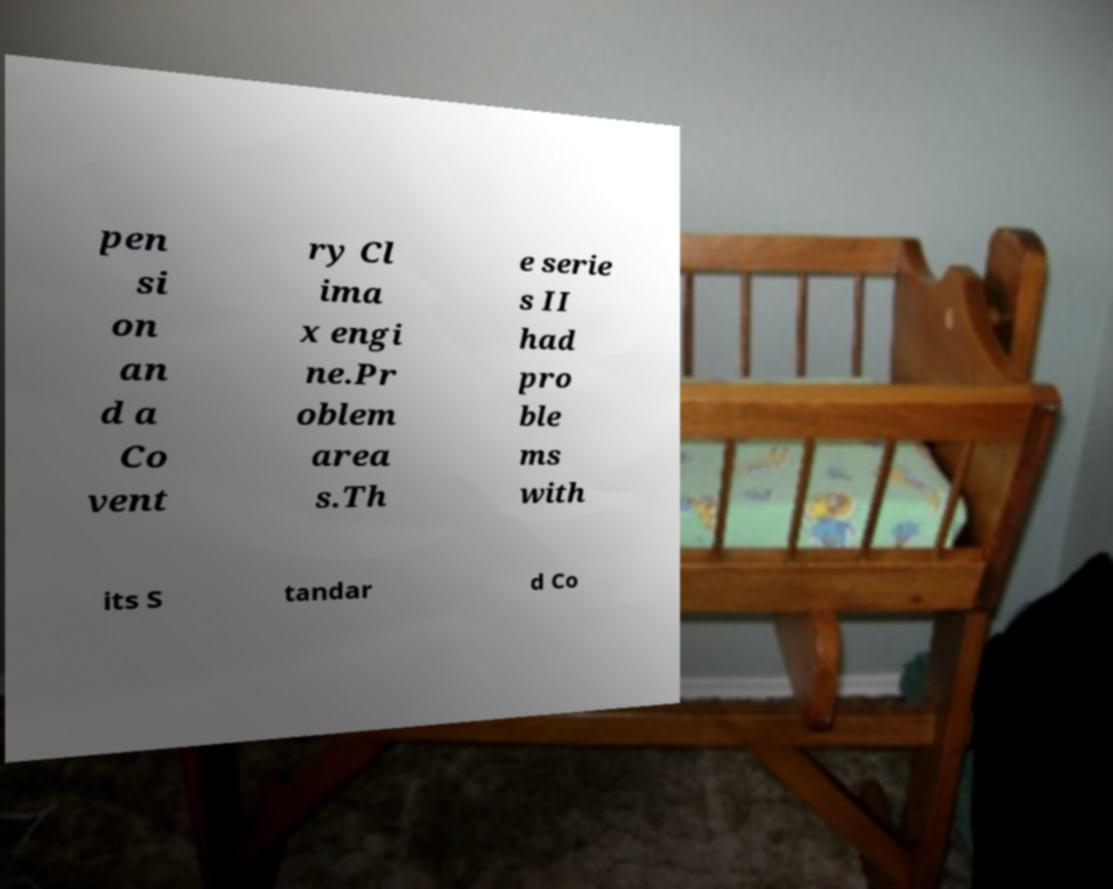There's text embedded in this image that I need extracted. Can you transcribe it verbatim? pen si on an d a Co vent ry Cl ima x engi ne.Pr oblem area s.Th e serie s II had pro ble ms with its S tandar d Co 